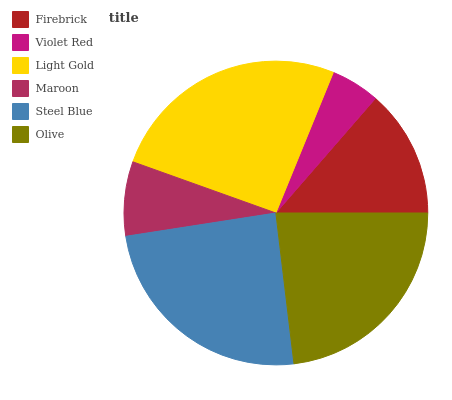Is Violet Red the minimum?
Answer yes or no. Yes. Is Light Gold the maximum?
Answer yes or no. Yes. Is Light Gold the minimum?
Answer yes or no. No. Is Violet Red the maximum?
Answer yes or no. No. Is Light Gold greater than Violet Red?
Answer yes or no. Yes. Is Violet Red less than Light Gold?
Answer yes or no. Yes. Is Violet Red greater than Light Gold?
Answer yes or no. No. Is Light Gold less than Violet Red?
Answer yes or no. No. Is Olive the high median?
Answer yes or no. Yes. Is Firebrick the low median?
Answer yes or no. Yes. Is Steel Blue the high median?
Answer yes or no. No. Is Light Gold the low median?
Answer yes or no. No. 